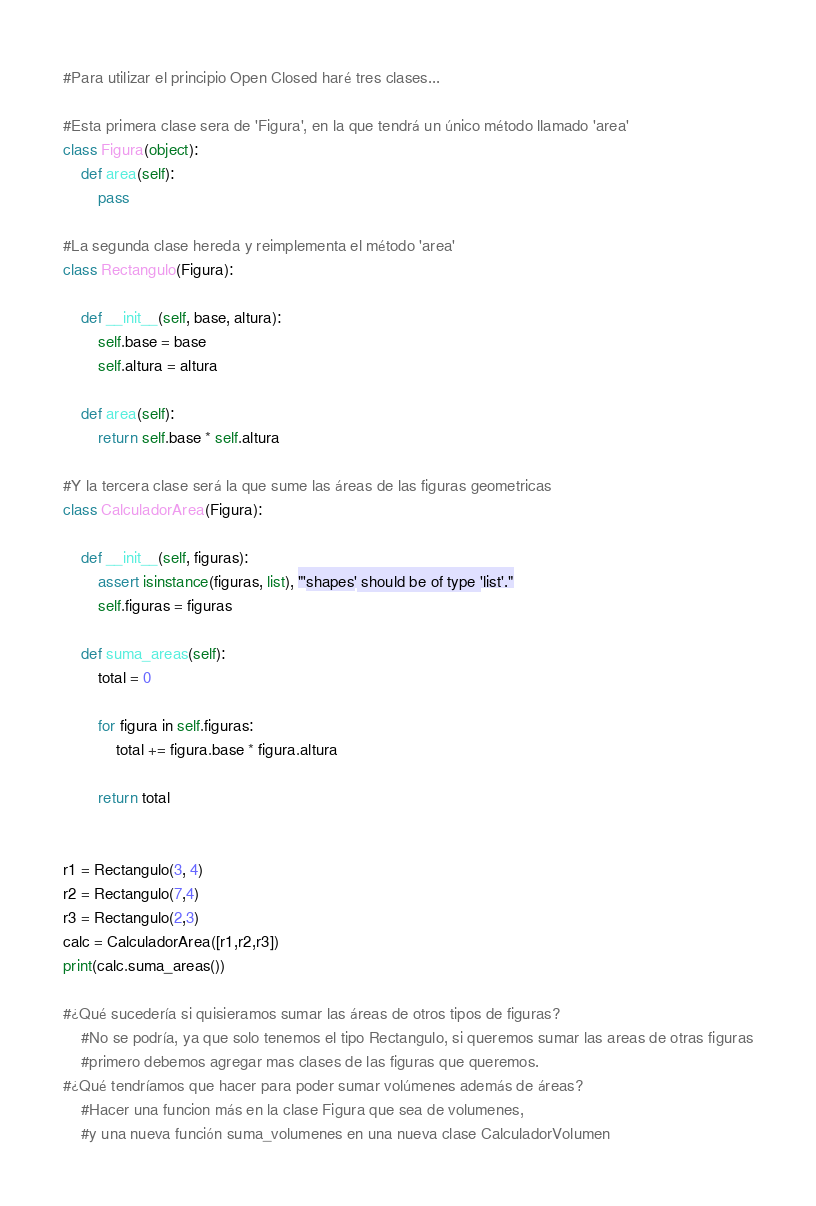Convert code to text. <code><loc_0><loc_0><loc_500><loc_500><_Python_>#Para utilizar el principio Open Closed haré tres clases...

#Esta primera clase sera de 'Figura', en la que tendrá un único método llamado 'area'
class Figura(object):
    def area(self):
        pass

#La segunda clase hereda y reimplementa el método 'area'
class Rectangulo(Figura):

    def __init__(self, base, altura):
        self.base = base
        self.altura = altura

    def area(self):
        return self.base * self.altura

#Y la tercera clase será la que sume las áreas de las figuras geometricas
class CalculadorArea(Figura):

    def __init__(self, figuras):
        assert isinstance(figuras, list), "'shapes' should be of type 'list'."
        self.figuras = figuras

    def suma_areas(self):
        total = 0

        for figura in self.figuras:
            total += figura.base * figura.altura

        return total


r1 = Rectangulo(3, 4)
r2 = Rectangulo(7,4)
r3 = Rectangulo(2,3)
calc = CalculadorArea([r1,r2,r3])
print(calc.suma_areas())

#¿Qué sucedería si quisieramos sumar las áreas de otros tipos de figuras?
    #No se podría, ya que solo tenemos el tipo Rectangulo, si queremos sumar las areas de otras figuras
    #primero debemos agregar mas clases de las figuras que queremos.
#¿Qué tendríamos que hacer para poder sumar volúmenes además de áreas?
    #Hacer una funcion más en la clase Figura que sea de volumenes,
    #y una nueva función suma_volumenes en una nueva clase CalculadorVolumen</code> 